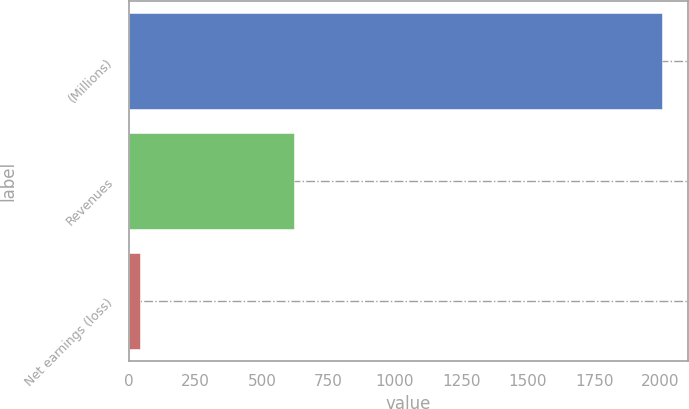Convert chart to OTSL. <chart><loc_0><loc_0><loc_500><loc_500><bar_chart><fcel>(Millions)<fcel>Revenues<fcel>Net earnings (loss)<nl><fcel>2004<fcel>622<fcel>42<nl></chart> 